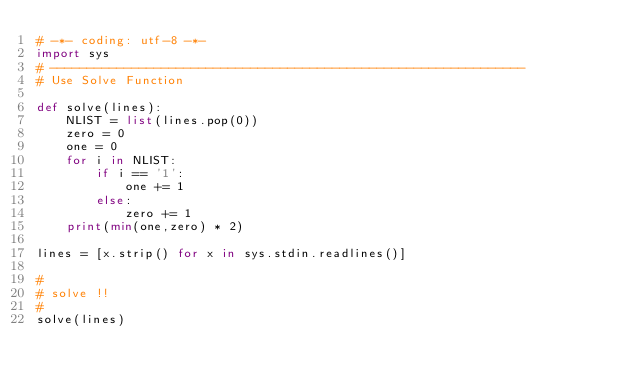Convert code to text. <code><loc_0><loc_0><loc_500><loc_500><_Python_># -*- coding: utf-8 -*-
import sys
# ----------------------------------------------------------------
# Use Solve Function

def solve(lines):
    NLIST = list(lines.pop(0))
    zero = 0
    one = 0
    for i in NLIST:
        if i == '1':
            one += 1
        else:
            zero += 1
    print(min(one,zero) * 2)
    
lines = [x.strip() for x in sys.stdin.readlines()]

#
# solve !!
#
solve(lines)</code> 